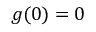Convert formula to latex. <formula><loc_0><loc_0><loc_500><loc_500>g ( 0 ) = 0</formula> 